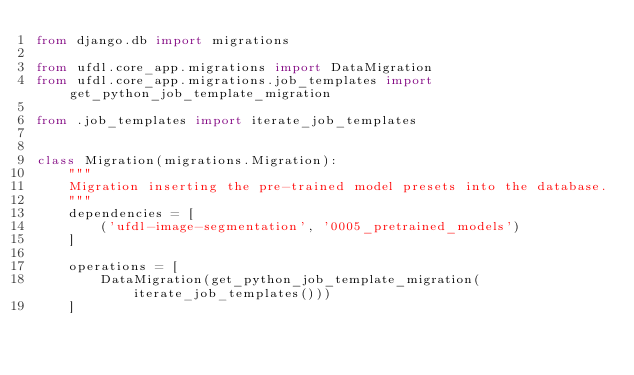<code> <loc_0><loc_0><loc_500><loc_500><_Python_>from django.db import migrations

from ufdl.core_app.migrations import DataMigration
from ufdl.core_app.migrations.job_templates import get_python_job_template_migration

from .job_templates import iterate_job_templates


class Migration(migrations.Migration):
    """
    Migration inserting the pre-trained model presets into the database.
    """
    dependencies = [
        ('ufdl-image-segmentation', '0005_pretrained_models')
    ]

    operations = [
        DataMigration(get_python_job_template_migration(iterate_job_templates()))
    ]
</code> 